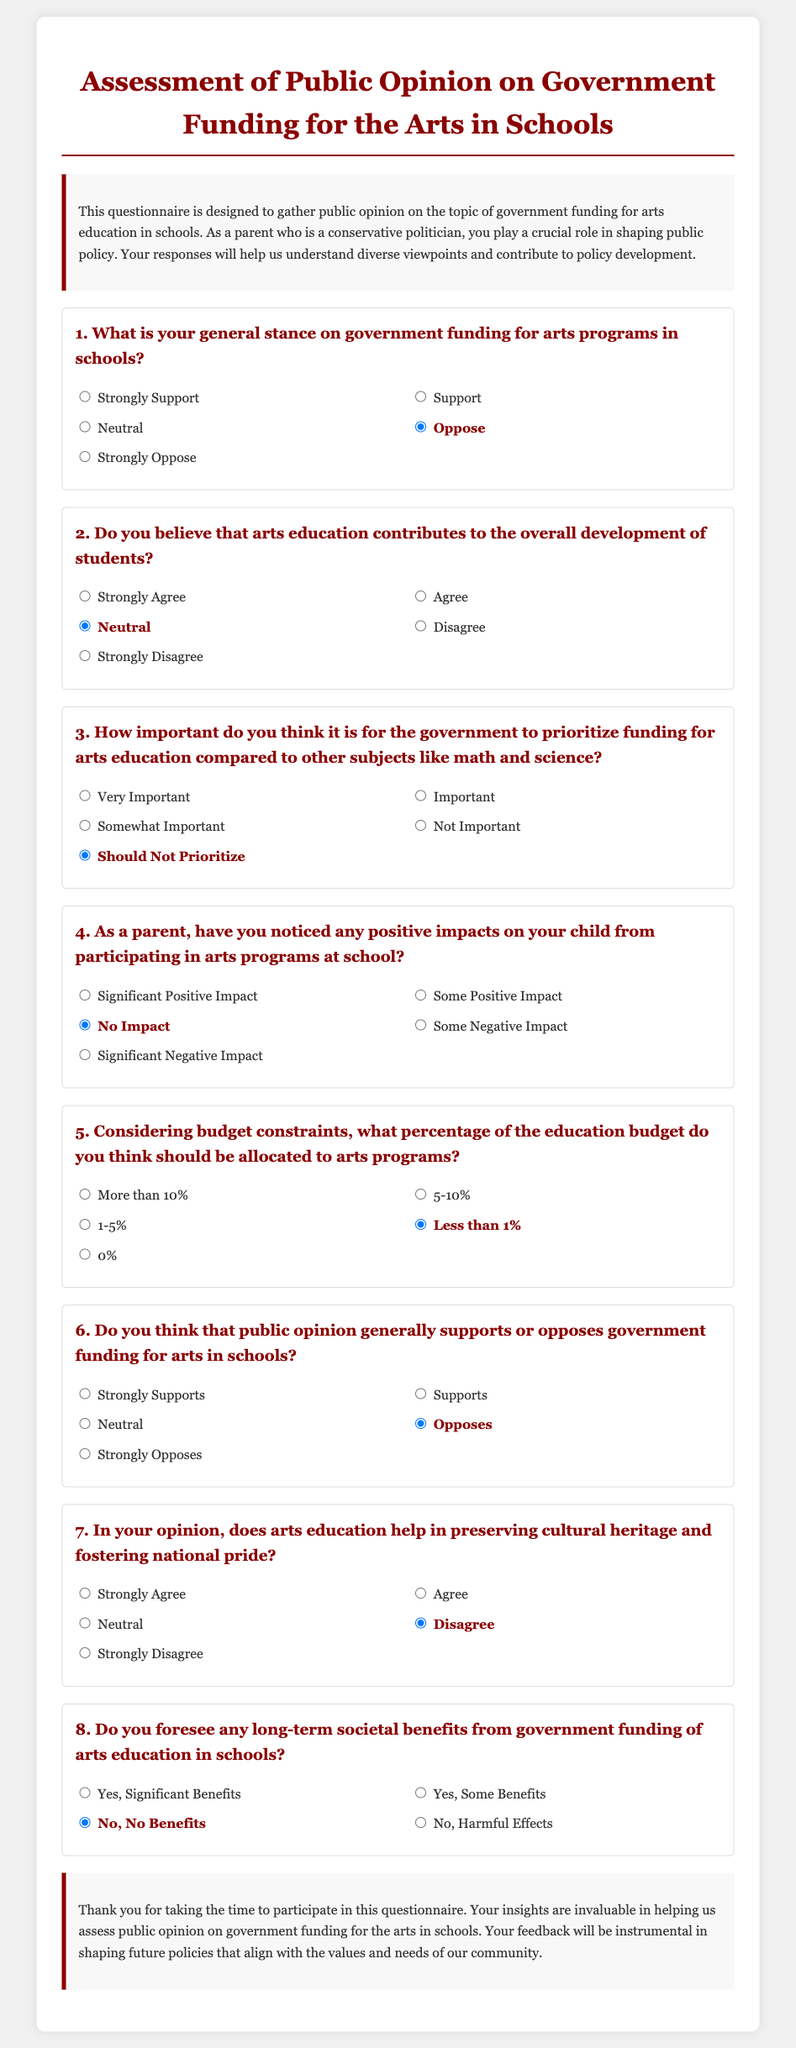What is the title of the document? The title, as stated in the document, is prominently displayed at the top of the container.
Answer: Assessment of Public Opinion on Government Funding for the Arts in Schools How many questions are included in the questionnaire? The document contains a series of questions within the questionnaire, each structured to gather opinions.
Answer: 8 What stance does the document suggest the parent has towards government funding for arts programs? The options in the first question indicate that the stance favored in the document is against government funding.
Answer: Oppose What percentage of the education budget does the document suggest should be allocated to arts programs? The document provides options for respondents to select a percentage allocation for arts funding, with a specific option mentioned.
Answer: Less than 1% Does the document state that public opinion generally supports government funding for arts in schools? The options provided for public opinion indicate a prevailing negative stance toward funding in the document.
Answer: Opposes What is the general opinion stated about arts education contributing to overall student development? The responses indicate a neutral stance regarding arts education's contribution to student development, as highlighted in the second question.
Answer: Neutral What response option did the document provide for the perceived impact of arts programs on the child? The options include various perceptions of impact, and a specific one indicates no perceived impact.
Answer: No Impact How does the document suggest the government should prioritize funding for arts education compared to other subjects? The responses indicate a view that arts education should not be prioritized, as reflected in question three.
Answer: Should Not Prioritize 